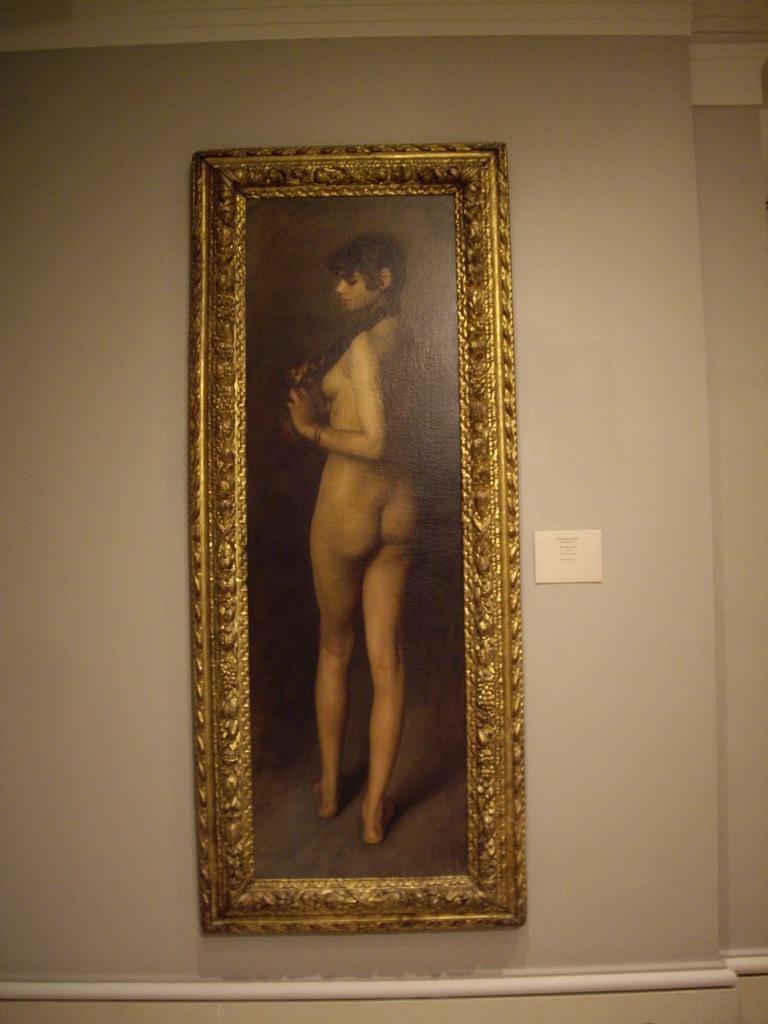Describe this image in one or two sentences. In this image I can see the frame attached to the wall. In the frame I can see the person standing. 